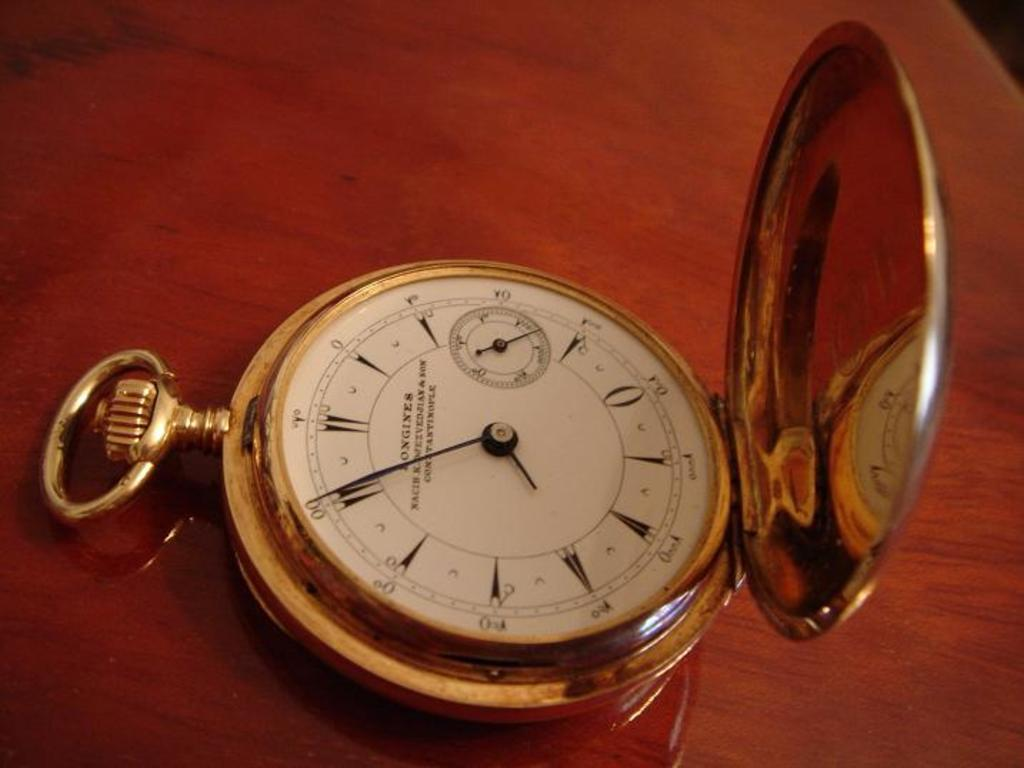<image>
Create a compact narrative representing the image presented. A gold Longines pocket watch is open on a wooden table. 